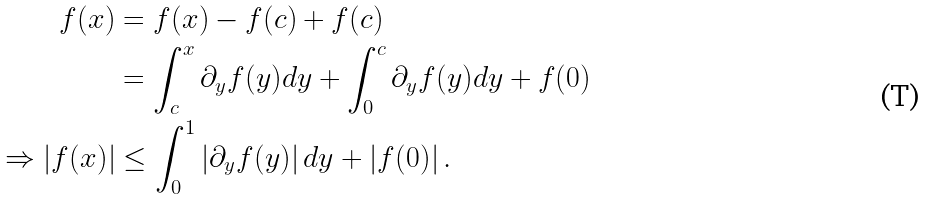Convert formula to latex. <formula><loc_0><loc_0><loc_500><loc_500>f ( x ) & = f ( x ) - f ( c ) + f ( c ) \\ & = \int _ { c } ^ { x } \partial _ { y } f ( y ) d y + \int _ { 0 } ^ { c } \partial _ { y } f ( y ) d y + f ( 0 ) \\ \Rightarrow \left | f ( x ) \right | & \leq \int _ { 0 } ^ { 1 } \left | \partial _ { y } f ( y ) \right | d y + \left | f ( 0 ) \right | .</formula> 